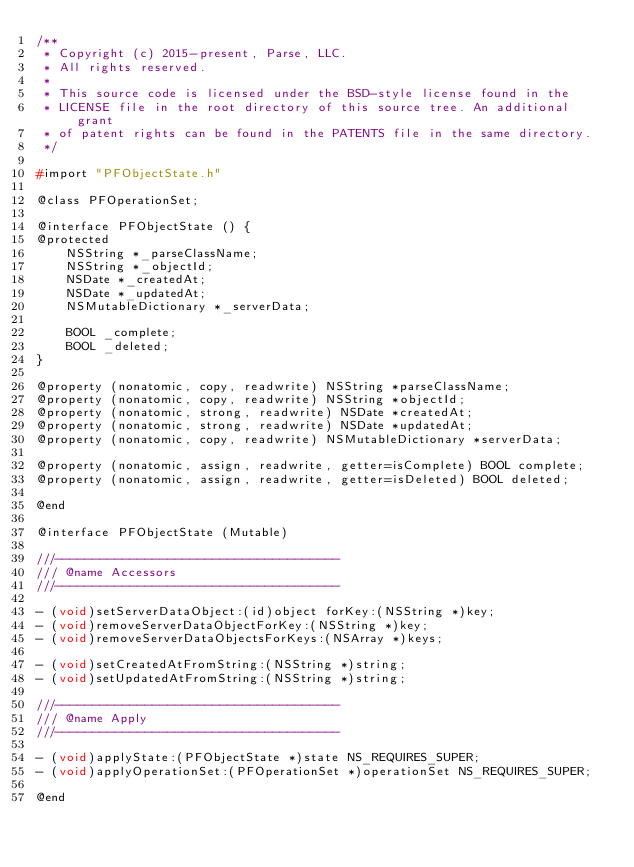<code> <loc_0><loc_0><loc_500><loc_500><_C_>/**
 * Copyright (c) 2015-present, Parse, LLC.
 * All rights reserved.
 *
 * This source code is licensed under the BSD-style license found in the
 * LICENSE file in the root directory of this source tree. An additional grant
 * of patent rights can be found in the PATENTS file in the same directory.
 */

#import "PFObjectState.h"

@class PFOperationSet;

@interface PFObjectState () {
@protected
    NSString *_parseClassName;
    NSString *_objectId;
    NSDate *_createdAt;
    NSDate *_updatedAt;
    NSMutableDictionary *_serverData;

    BOOL _complete;
    BOOL _deleted;
}

@property (nonatomic, copy, readwrite) NSString *parseClassName;
@property (nonatomic, copy, readwrite) NSString *objectId;
@property (nonatomic, strong, readwrite) NSDate *createdAt;
@property (nonatomic, strong, readwrite) NSDate *updatedAt;
@property (nonatomic, copy, readwrite) NSMutableDictionary *serverData;

@property (nonatomic, assign, readwrite, getter=isComplete) BOOL complete;
@property (nonatomic, assign, readwrite, getter=isDeleted) BOOL deleted;

@end

@interface PFObjectState (Mutable)

///--------------------------------------
/// @name Accessors
///--------------------------------------

- (void)setServerDataObject:(id)object forKey:(NSString *)key;
- (void)removeServerDataObjectForKey:(NSString *)key;
- (void)removeServerDataObjectsForKeys:(NSArray *)keys;

- (void)setCreatedAtFromString:(NSString *)string;
- (void)setUpdatedAtFromString:(NSString *)string;

///--------------------------------------
/// @name Apply
///--------------------------------------

- (void)applyState:(PFObjectState *)state NS_REQUIRES_SUPER;
- (void)applyOperationSet:(PFOperationSet *)operationSet NS_REQUIRES_SUPER;

@end
</code> 